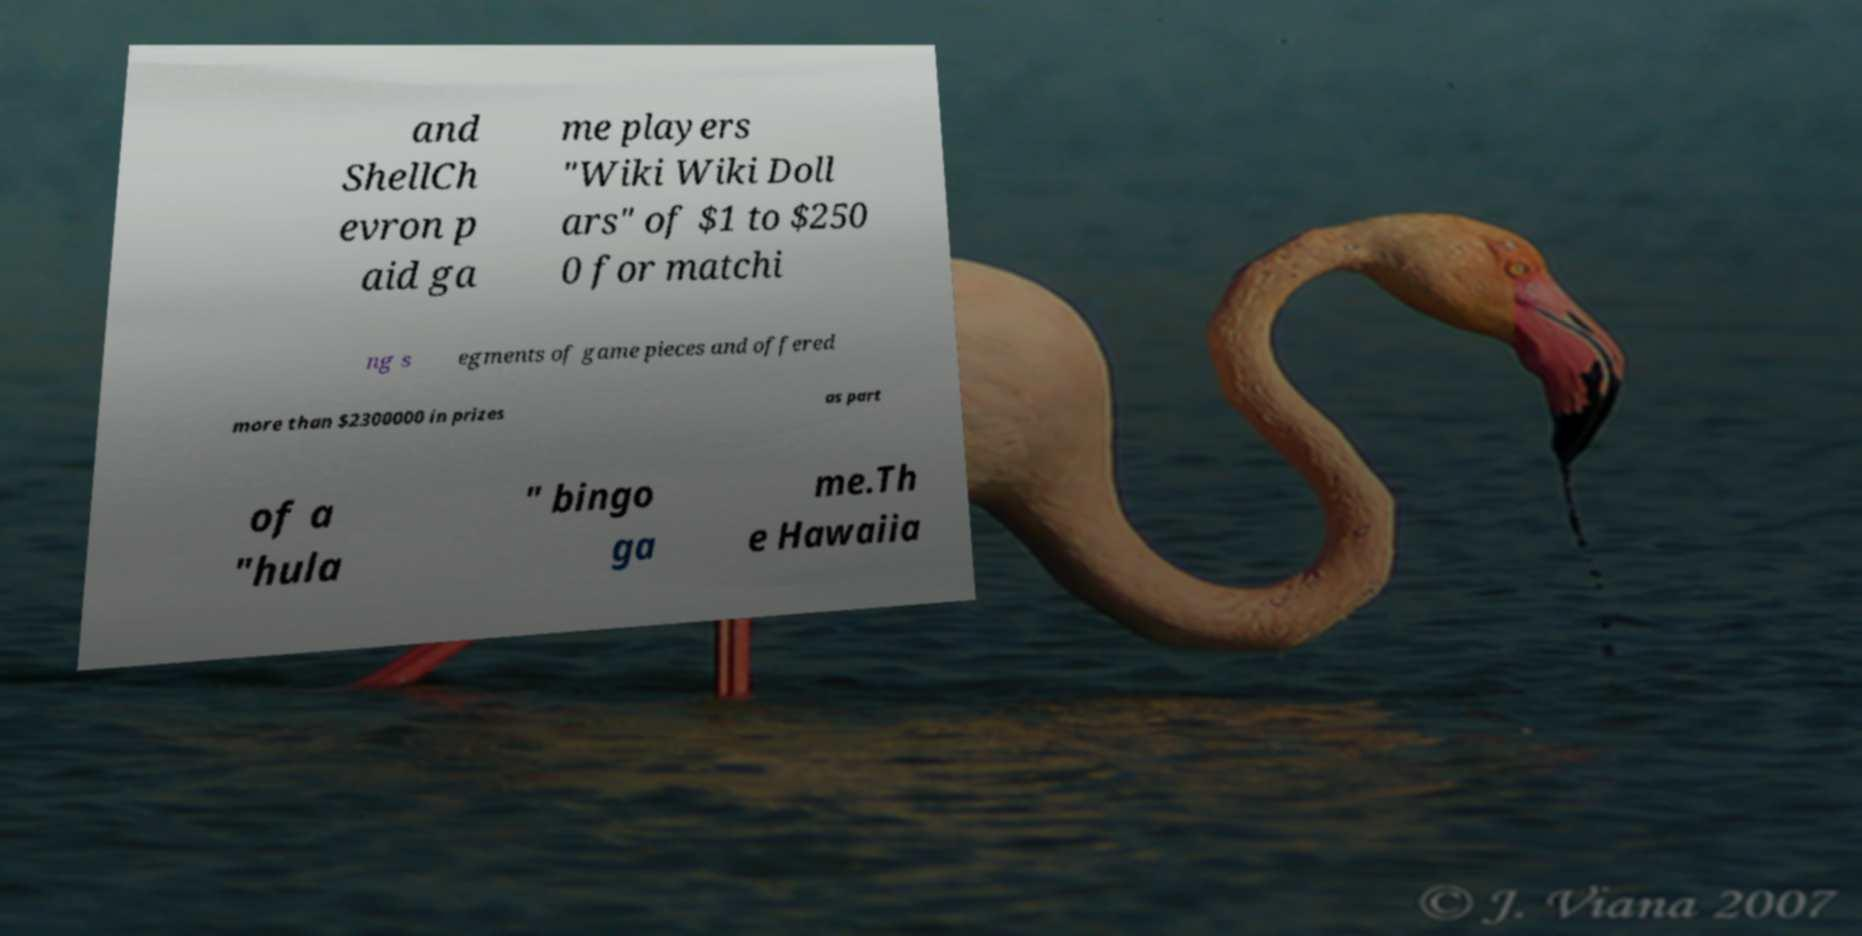I need the written content from this picture converted into text. Can you do that? and ShellCh evron p aid ga me players "Wiki Wiki Doll ars" of $1 to $250 0 for matchi ng s egments of game pieces and offered more than $2300000 in prizes as part of a "hula " bingo ga me.Th e Hawaiia 